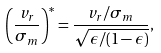Convert formula to latex. <formula><loc_0><loc_0><loc_500><loc_500>\left ( \frac { v _ { r } } { \sigma _ { m } } \right ) ^ { \ast } = \frac { v _ { r } / \sigma _ { m } } { \sqrt { \epsilon / ( 1 - \epsilon ) } } ,</formula> 